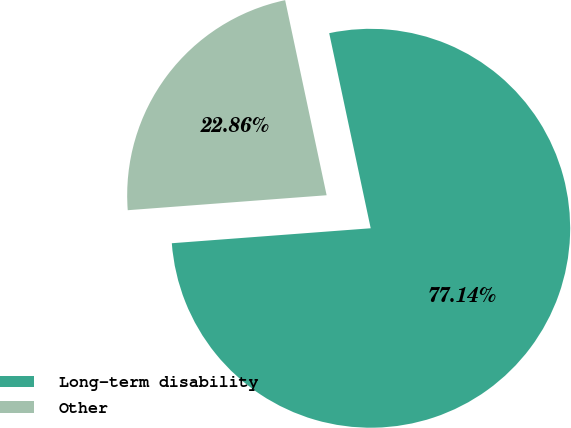Convert chart to OTSL. <chart><loc_0><loc_0><loc_500><loc_500><pie_chart><fcel>Long-term disability<fcel>Other<nl><fcel>77.14%<fcel>22.86%<nl></chart> 